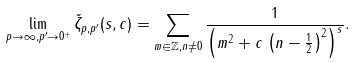Convert formula to latex. <formula><loc_0><loc_0><loc_500><loc_500>\lim _ { p \rightarrow \infty , p ^ { \prime } \rightarrow 0 ^ { + } } \tilde { \zeta } _ { p , p ^ { \prime } } ( s , c ) = \sum _ { m \in \mathbb { Z } , n \neq 0 } \frac { 1 } { \left ( m ^ { 2 } + c \, \left ( n - \frac { 1 } { 2 } \right ) ^ { 2 } \right ) ^ { s } } .</formula> 